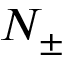Convert formula to latex. <formula><loc_0><loc_0><loc_500><loc_500>N _ { \pm }</formula> 